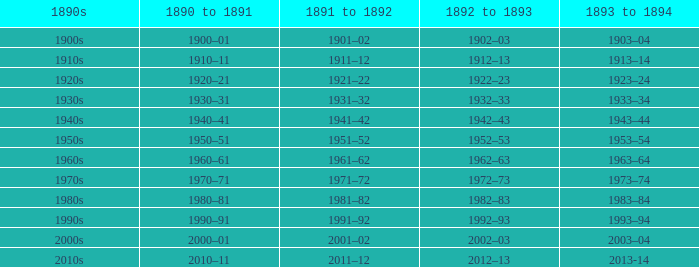What is the year from 1892-93 that has the 1890s to the 1940s? 1942–43. 